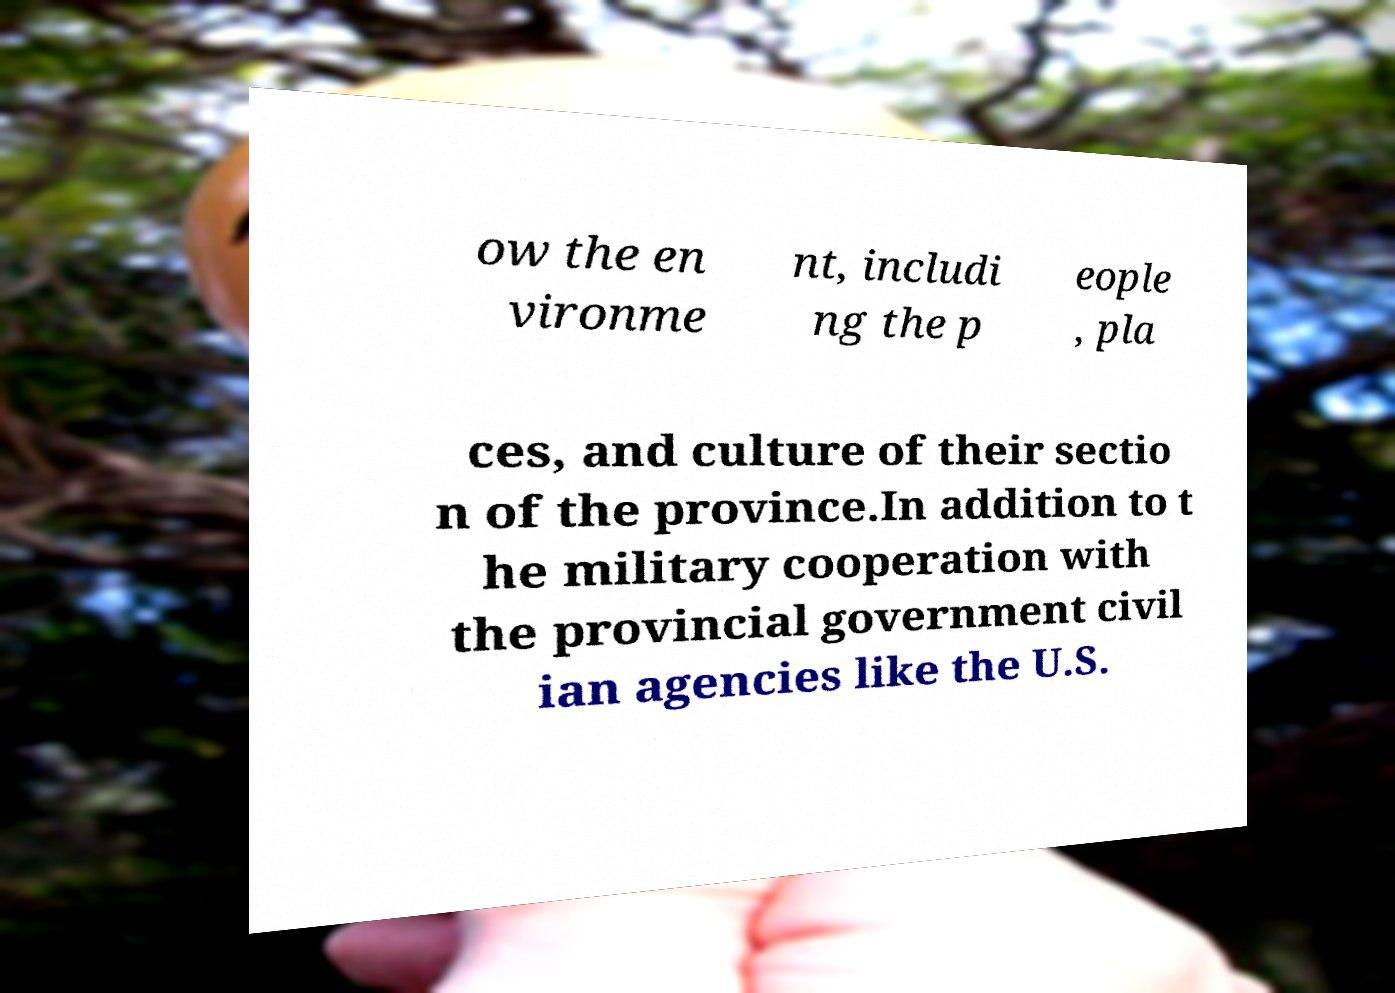For documentation purposes, I need the text within this image transcribed. Could you provide that? ow the en vironme nt, includi ng the p eople , pla ces, and culture of their sectio n of the province.In addition to t he military cooperation with the provincial government civil ian agencies like the U.S. 